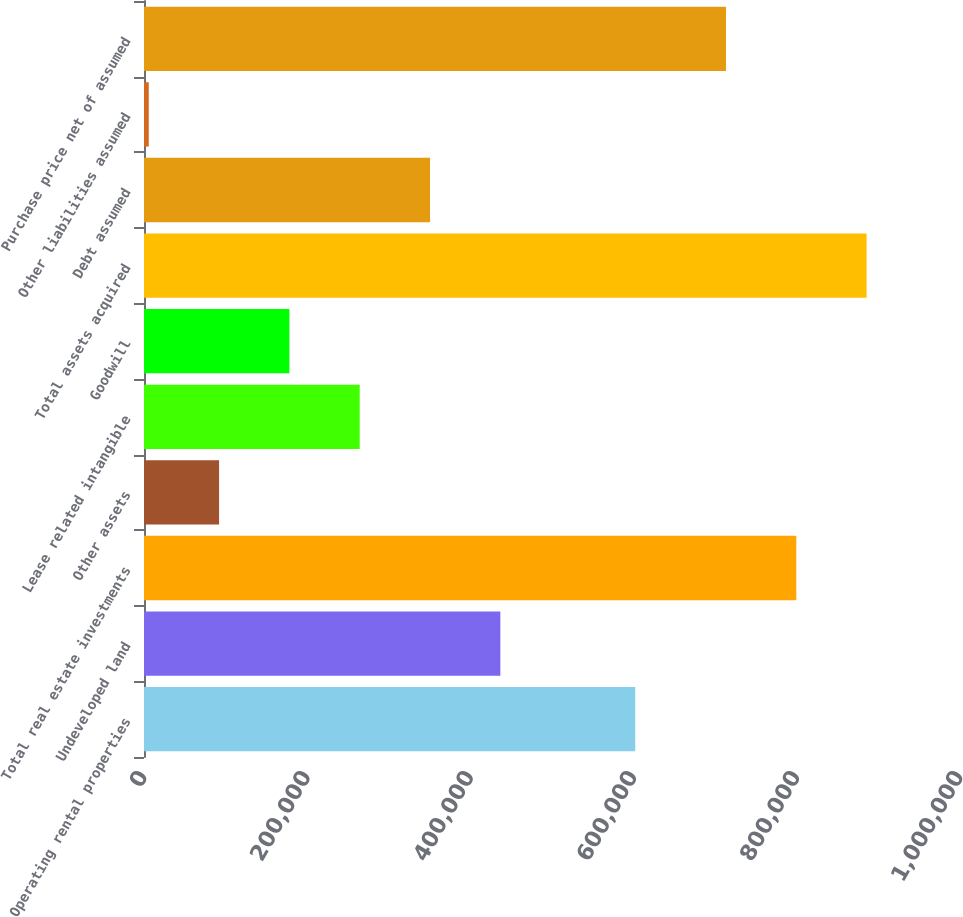<chart> <loc_0><loc_0><loc_500><loc_500><bar_chart><fcel>Operating rental properties<fcel>Undeveloped land<fcel>Total real estate investments<fcel>Other assets<fcel>Lease related intangible<fcel>Goodwill<fcel>Total assets acquired<fcel>Debt assumed<fcel>Other liabilities assumed<fcel>Purchase price net of assumed<nl><fcel>602011<fcel>436694<fcel>799375<fcel>92001.9<fcel>264348<fcel>178175<fcel>885548<fcel>350521<fcel>5829<fcel>713202<nl></chart> 